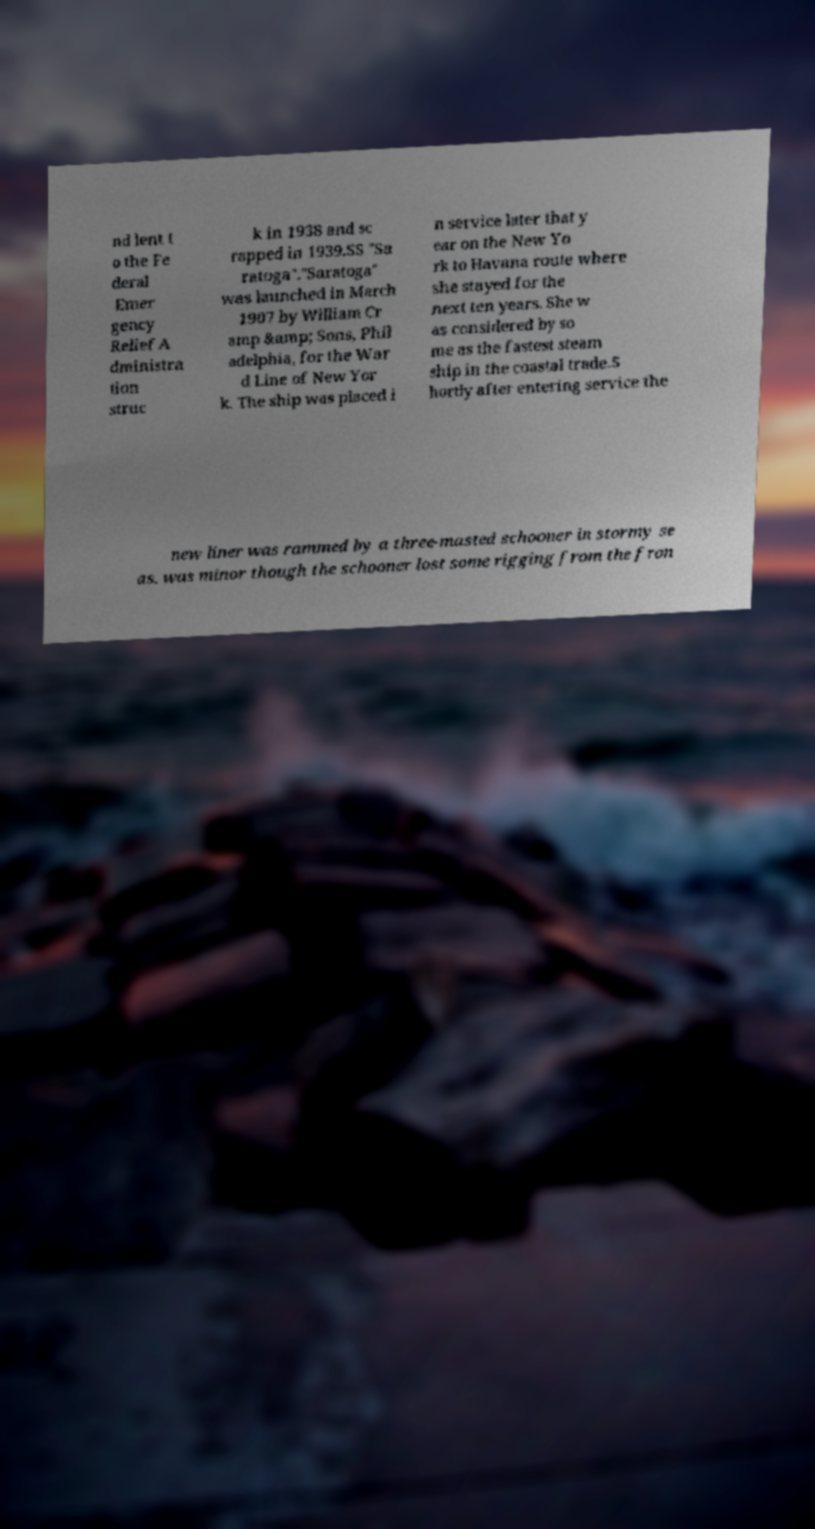Can you read and provide the text displayed in the image?This photo seems to have some interesting text. Can you extract and type it out for me? nd lent t o the Fe deral Emer gency Relief A dministra tion struc k in 1938 and sc rapped in 1939.SS "Sa ratoga"."Saratoga" was launched in March 1907 by William Cr amp &amp; Sons, Phil adelphia, for the War d Line of New Yor k. The ship was placed i n service later that y ear on the New Yo rk to Havana route where she stayed for the next ten years. She w as considered by so me as the fastest steam ship in the coastal trade.S hortly after entering service the new liner was rammed by a three-masted schooner in stormy se as. was minor though the schooner lost some rigging from the fron 